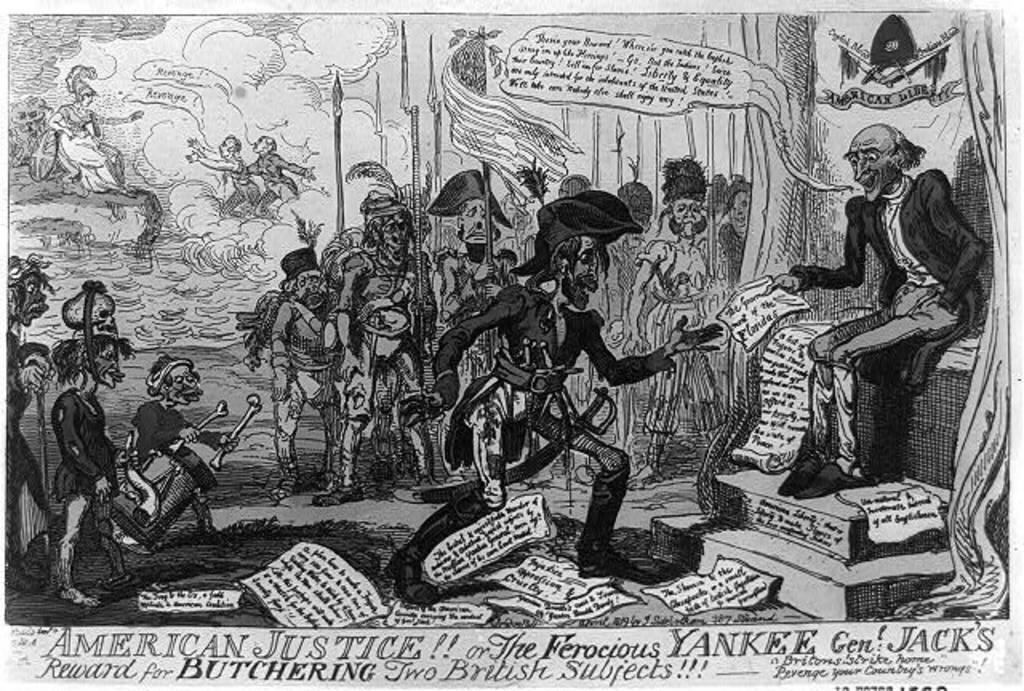What is the main subject in the image? There is a poster in the image. What else can be seen in the image besides the poster? There are people and objects visible in the image. What is written on the poster? There is text on the poster. What color is the daughter's notebook in the image? There is no daughter or notebook present in the image. What is the relation between the people in the image? The provided facts do not mention any specific relation between the people in the image. 